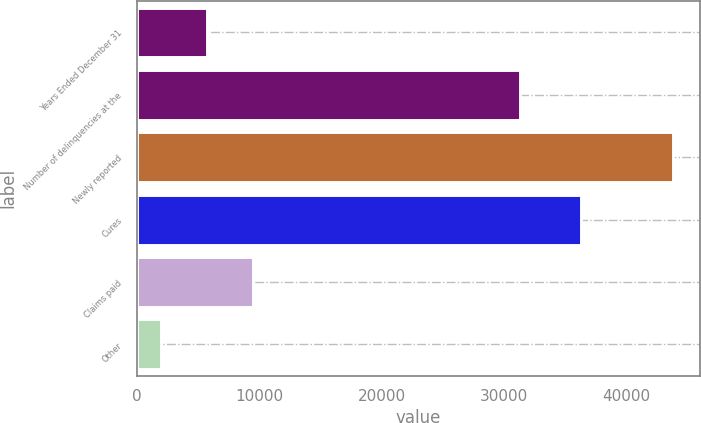<chart> <loc_0><loc_0><loc_500><loc_500><bar_chart><fcel>Years Ended December 31<fcel>Number of delinquencies at the<fcel>Newly reported<fcel>Cures<fcel>Claims paid<fcel>Other<nl><fcel>5726.8<fcel>31285<fcel>43810.6<fcel>36279<fcel>9492.6<fcel>1961<nl></chart> 